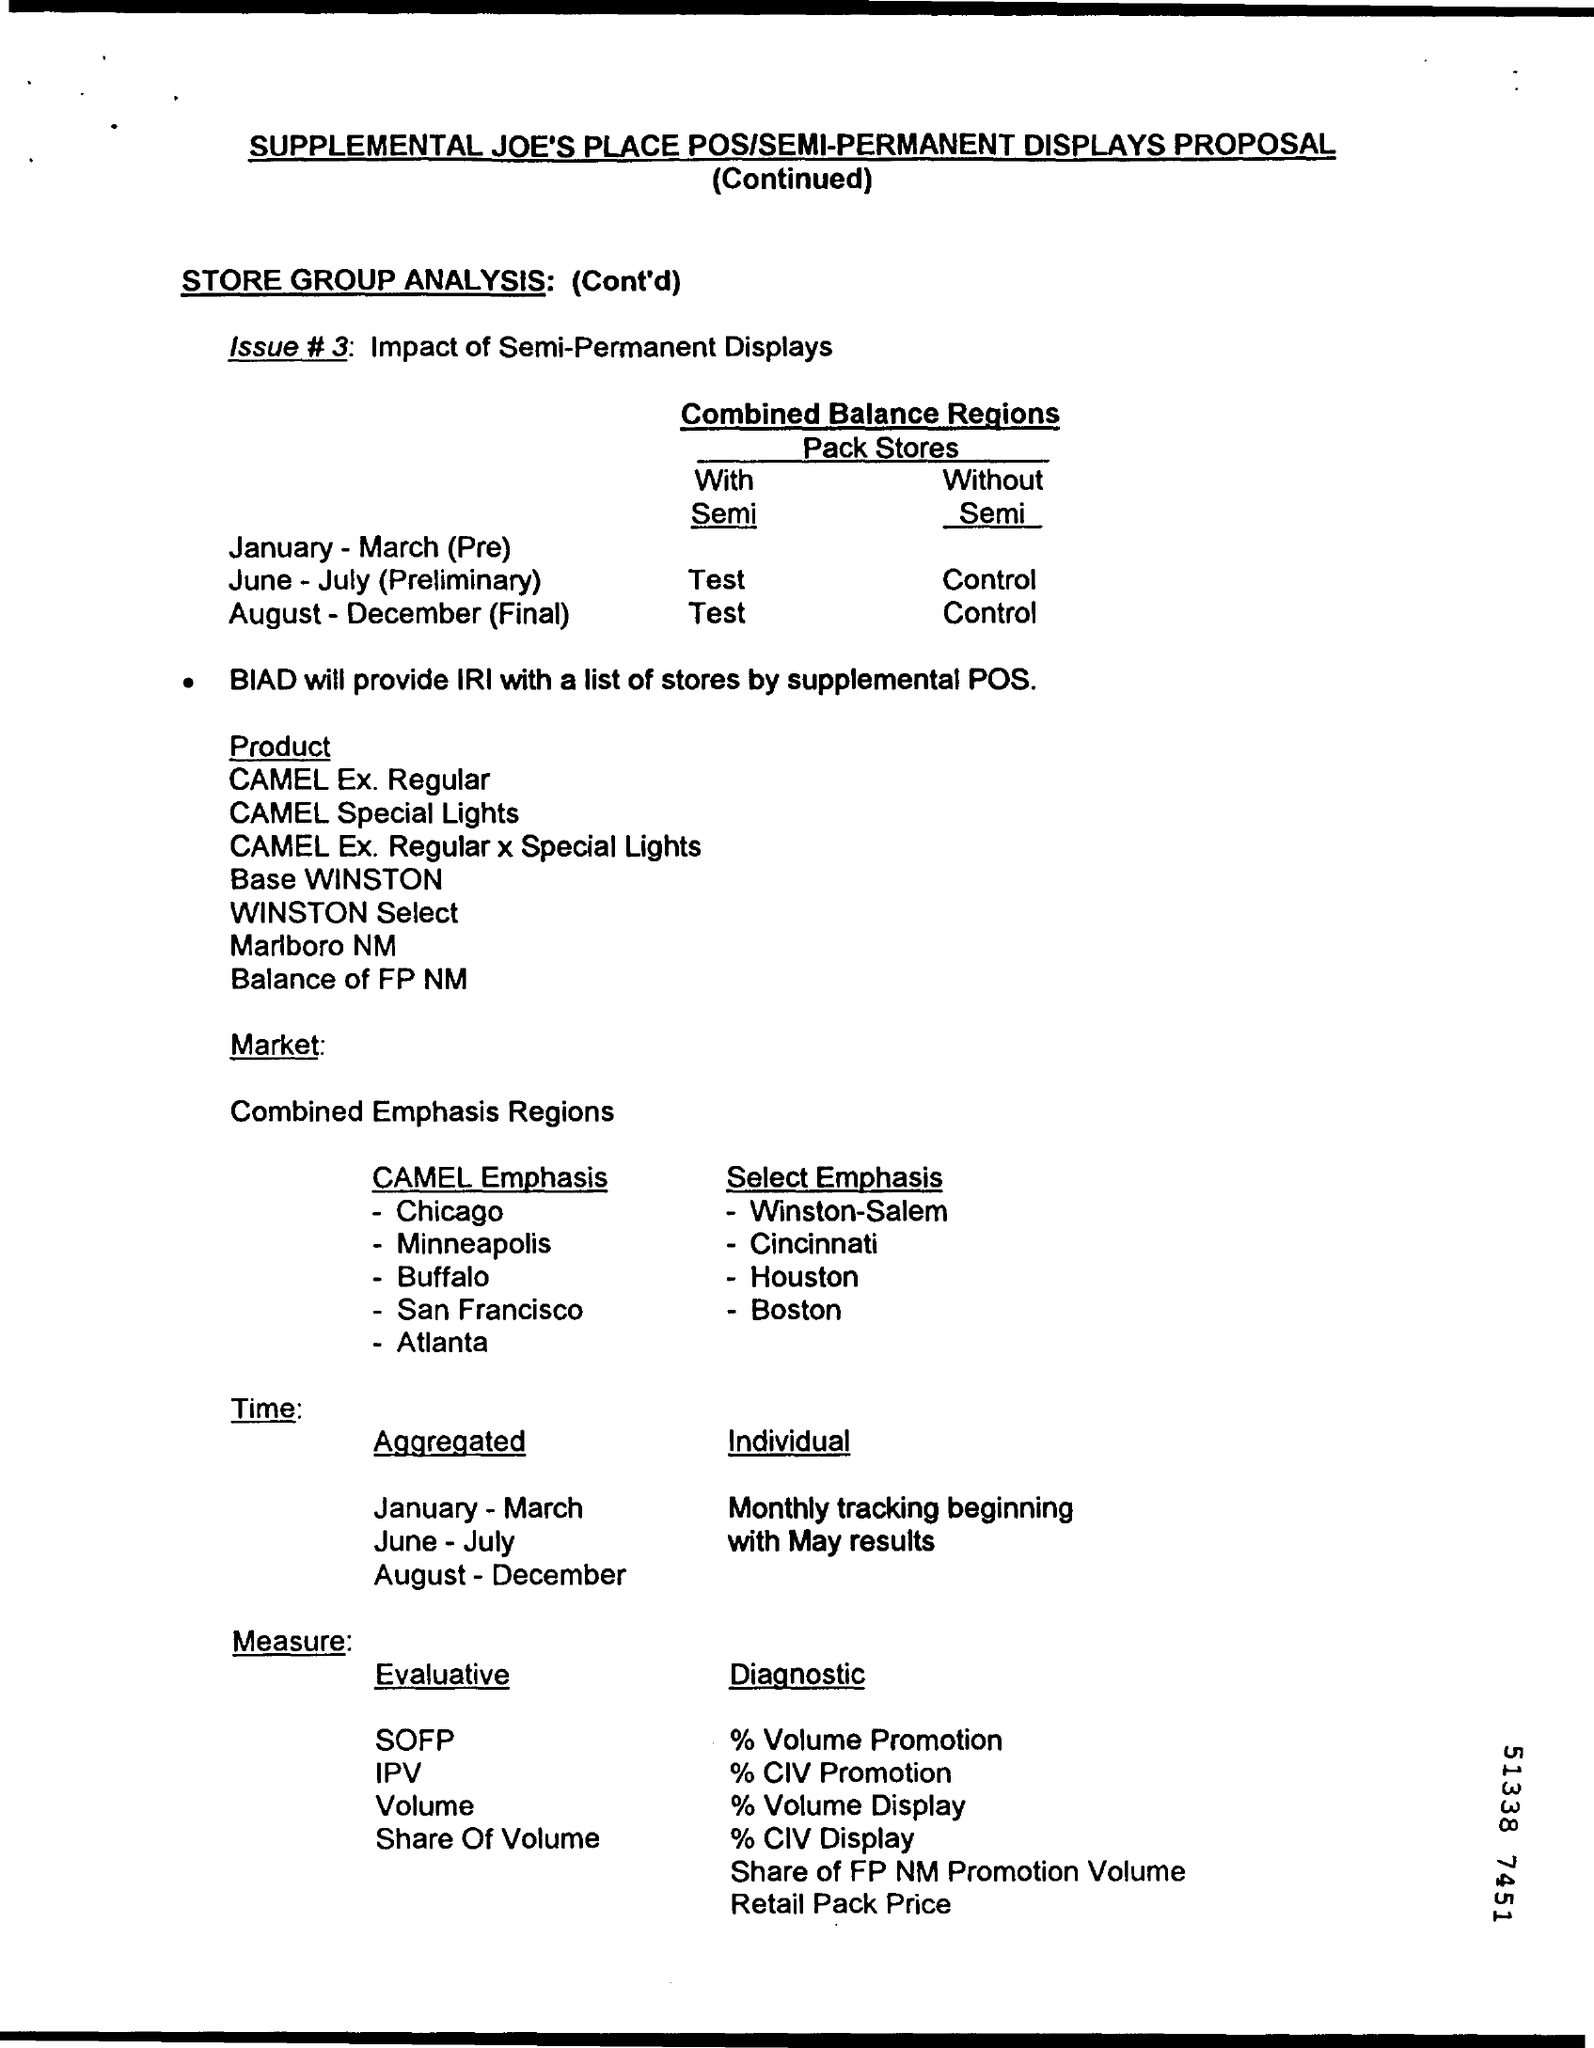Mention a couple of crucial points in this snapshot. The issue of semi-permanent displays is a matter of concern due to its potential impact on the environment and the need for effective regulation to balance the interests of all stakeholders. IRI will obtain a list of stores from BIAD for supplemental POS. 